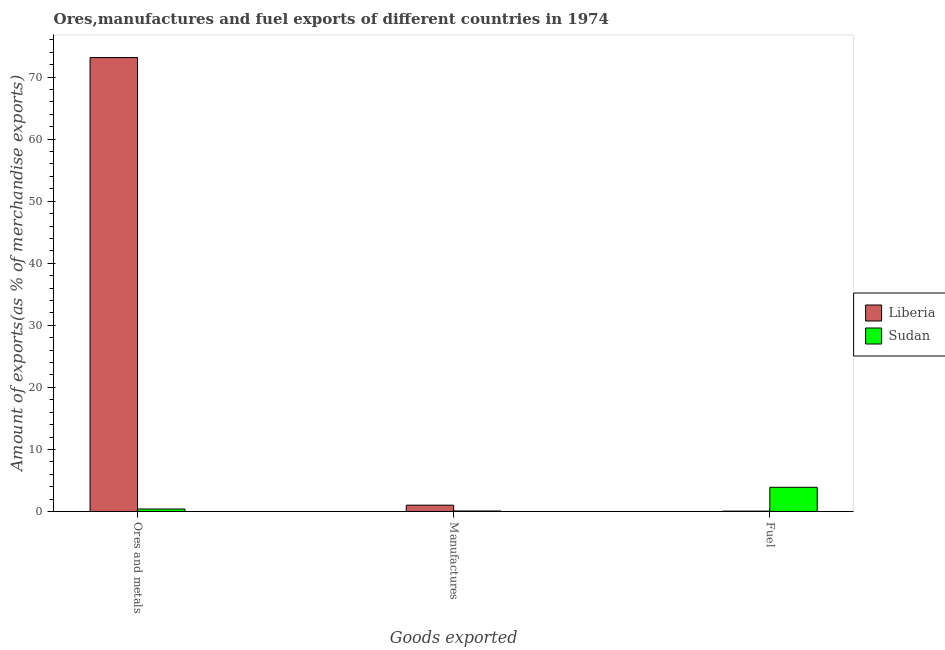How many different coloured bars are there?
Ensure brevity in your answer.  2. How many groups of bars are there?
Provide a succinct answer. 3. Are the number of bars per tick equal to the number of legend labels?
Offer a very short reply. Yes. How many bars are there on the 3rd tick from the left?
Your response must be concise. 2. How many bars are there on the 3rd tick from the right?
Give a very brief answer. 2. What is the label of the 1st group of bars from the left?
Offer a very short reply. Ores and metals. What is the percentage of manufactures exports in Liberia?
Keep it short and to the point. 1.02. Across all countries, what is the maximum percentage of manufactures exports?
Ensure brevity in your answer.  1.02. Across all countries, what is the minimum percentage of fuel exports?
Offer a very short reply. 0.05. In which country was the percentage of fuel exports maximum?
Your response must be concise. Sudan. In which country was the percentage of ores and metals exports minimum?
Give a very brief answer. Sudan. What is the total percentage of fuel exports in the graph?
Offer a terse response. 3.95. What is the difference between the percentage of manufactures exports in Liberia and that in Sudan?
Keep it short and to the point. 0.94. What is the difference between the percentage of fuel exports in Sudan and the percentage of ores and metals exports in Liberia?
Keep it short and to the point. -69.25. What is the average percentage of fuel exports per country?
Your answer should be compact. 1.98. What is the difference between the percentage of fuel exports and percentage of manufactures exports in Sudan?
Your answer should be compact. 3.82. What is the ratio of the percentage of fuel exports in Liberia to that in Sudan?
Offer a very short reply. 0.01. What is the difference between the highest and the second highest percentage of fuel exports?
Give a very brief answer. 3.84. What is the difference between the highest and the lowest percentage of fuel exports?
Your response must be concise. 3.84. Is the sum of the percentage of fuel exports in Liberia and Sudan greater than the maximum percentage of manufactures exports across all countries?
Provide a succinct answer. Yes. What does the 1st bar from the left in Fuel represents?
Provide a short and direct response. Liberia. What does the 1st bar from the right in Manufactures represents?
Your answer should be very brief. Sudan. Are all the bars in the graph horizontal?
Keep it short and to the point. No. What is the difference between two consecutive major ticks on the Y-axis?
Give a very brief answer. 10. Does the graph contain any zero values?
Your answer should be very brief. No. How are the legend labels stacked?
Make the answer very short. Vertical. What is the title of the graph?
Make the answer very short. Ores,manufactures and fuel exports of different countries in 1974. What is the label or title of the X-axis?
Keep it short and to the point. Goods exported. What is the label or title of the Y-axis?
Ensure brevity in your answer.  Amount of exports(as % of merchandise exports). What is the Amount of exports(as % of merchandise exports) of Liberia in Ores and metals?
Offer a very short reply. 73.15. What is the Amount of exports(as % of merchandise exports) of Sudan in Ores and metals?
Provide a short and direct response. 0.4. What is the Amount of exports(as % of merchandise exports) of Liberia in Manufactures?
Keep it short and to the point. 1.02. What is the Amount of exports(as % of merchandise exports) of Sudan in Manufactures?
Keep it short and to the point. 0.08. What is the Amount of exports(as % of merchandise exports) in Liberia in Fuel?
Keep it short and to the point. 0.05. What is the Amount of exports(as % of merchandise exports) in Sudan in Fuel?
Your answer should be very brief. 3.9. Across all Goods exported, what is the maximum Amount of exports(as % of merchandise exports) in Liberia?
Ensure brevity in your answer.  73.15. Across all Goods exported, what is the maximum Amount of exports(as % of merchandise exports) in Sudan?
Your answer should be compact. 3.9. Across all Goods exported, what is the minimum Amount of exports(as % of merchandise exports) of Liberia?
Provide a succinct answer. 0.05. Across all Goods exported, what is the minimum Amount of exports(as % of merchandise exports) in Sudan?
Keep it short and to the point. 0.08. What is the total Amount of exports(as % of merchandise exports) of Liberia in the graph?
Provide a succinct answer. 74.22. What is the total Amount of exports(as % of merchandise exports) in Sudan in the graph?
Keep it short and to the point. 4.37. What is the difference between the Amount of exports(as % of merchandise exports) of Liberia in Ores and metals and that in Manufactures?
Make the answer very short. 72.13. What is the difference between the Amount of exports(as % of merchandise exports) in Sudan in Ores and metals and that in Manufactures?
Offer a very short reply. 0.32. What is the difference between the Amount of exports(as % of merchandise exports) of Liberia in Ores and metals and that in Fuel?
Ensure brevity in your answer.  73.09. What is the difference between the Amount of exports(as % of merchandise exports) in Sudan in Ores and metals and that in Fuel?
Keep it short and to the point. -3.5. What is the difference between the Amount of exports(as % of merchandise exports) of Liberia in Manufactures and that in Fuel?
Provide a succinct answer. 0.96. What is the difference between the Amount of exports(as % of merchandise exports) in Sudan in Manufactures and that in Fuel?
Your answer should be compact. -3.82. What is the difference between the Amount of exports(as % of merchandise exports) in Liberia in Ores and metals and the Amount of exports(as % of merchandise exports) in Sudan in Manufactures?
Offer a terse response. 73.07. What is the difference between the Amount of exports(as % of merchandise exports) of Liberia in Ores and metals and the Amount of exports(as % of merchandise exports) of Sudan in Fuel?
Provide a short and direct response. 69.25. What is the difference between the Amount of exports(as % of merchandise exports) in Liberia in Manufactures and the Amount of exports(as % of merchandise exports) in Sudan in Fuel?
Provide a succinct answer. -2.88. What is the average Amount of exports(as % of merchandise exports) in Liberia per Goods exported?
Your answer should be very brief. 24.74. What is the average Amount of exports(as % of merchandise exports) in Sudan per Goods exported?
Offer a very short reply. 1.46. What is the difference between the Amount of exports(as % of merchandise exports) in Liberia and Amount of exports(as % of merchandise exports) in Sudan in Ores and metals?
Provide a short and direct response. 72.75. What is the difference between the Amount of exports(as % of merchandise exports) of Liberia and Amount of exports(as % of merchandise exports) of Sudan in Manufactures?
Your answer should be compact. 0.94. What is the difference between the Amount of exports(as % of merchandise exports) of Liberia and Amount of exports(as % of merchandise exports) of Sudan in Fuel?
Offer a terse response. -3.84. What is the ratio of the Amount of exports(as % of merchandise exports) in Liberia in Ores and metals to that in Manufactures?
Offer a terse response. 71.97. What is the ratio of the Amount of exports(as % of merchandise exports) of Sudan in Ores and metals to that in Manufactures?
Offer a very short reply. 5.05. What is the ratio of the Amount of exports(as % of merchandise exports) in Liberia in Ores and metals to that in Fuel?
Ensure brevity in your answer.  1344.07. What is the ratio of the Amount of exports(as % of merchandise exports) in Sudan in Ores and metals to that in Fuel?
Provide a succinct answer. 0.1. What is the ratio of the Amount of exports(as % of merchandise exports) in Liberia in Manufactures to that in Fuel?
Provide a short and direct response. 18.68. What is the ratio of the Amount of exports(as % of merchandise exports) of Sudan in Manufactures to that in Fuel?
Keep it short and to the point. 0.02. What is the difference between the highest and the second highest Amount of exports(as % of merchandise exports) in Liberia?
Make the answer very short. 72.13. What is the difference between the highest and the second highest Amount of exports(as % of merchandise exports) in Sudan?
Your answer should be very brief. 3.5. What is the difference between the highest and the lowest Amount of exports(as % of merchandise exports) of Liberia?
Offer a terse response. 73.09. What is the difference between the highest and the lowest Amount of exports(as % of merchandise exports) of Sudan?
Your answer should be very brief. 3.82. 